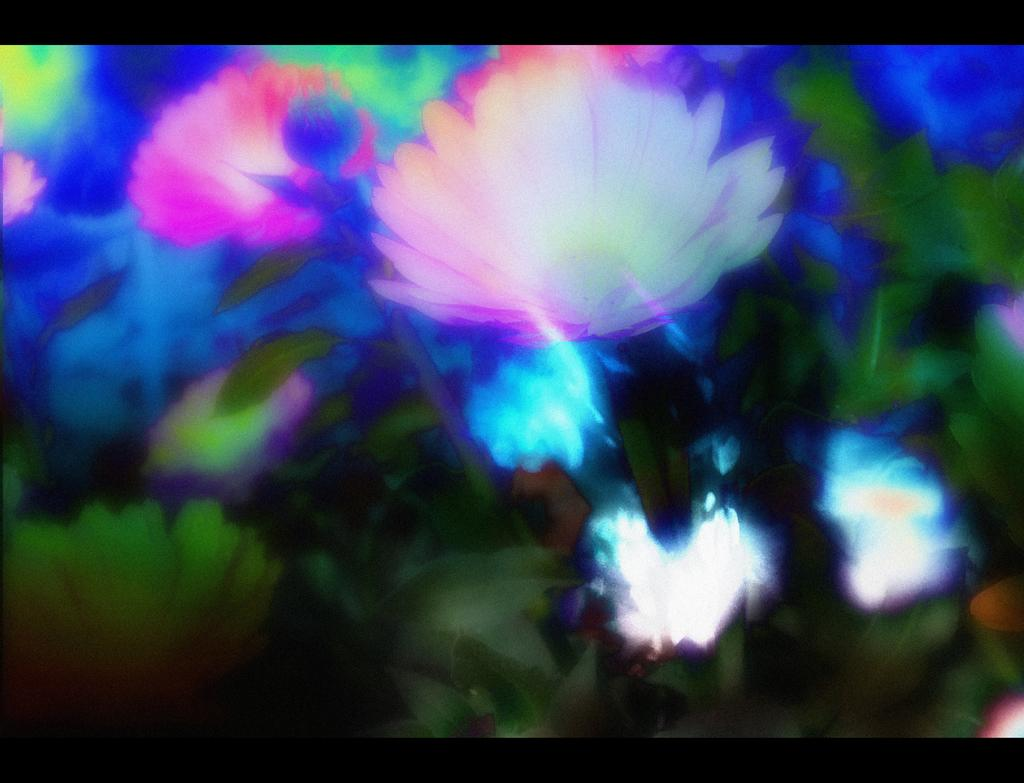What type of plants can be seen in the image? There are beautiful flowers in the image. What else can be seen in the image besides the flowers? There are leaves in the image. What group of people can be seen fighting in the image? There are no people or fights present in the image; it features beautiful flowers and leaves. 